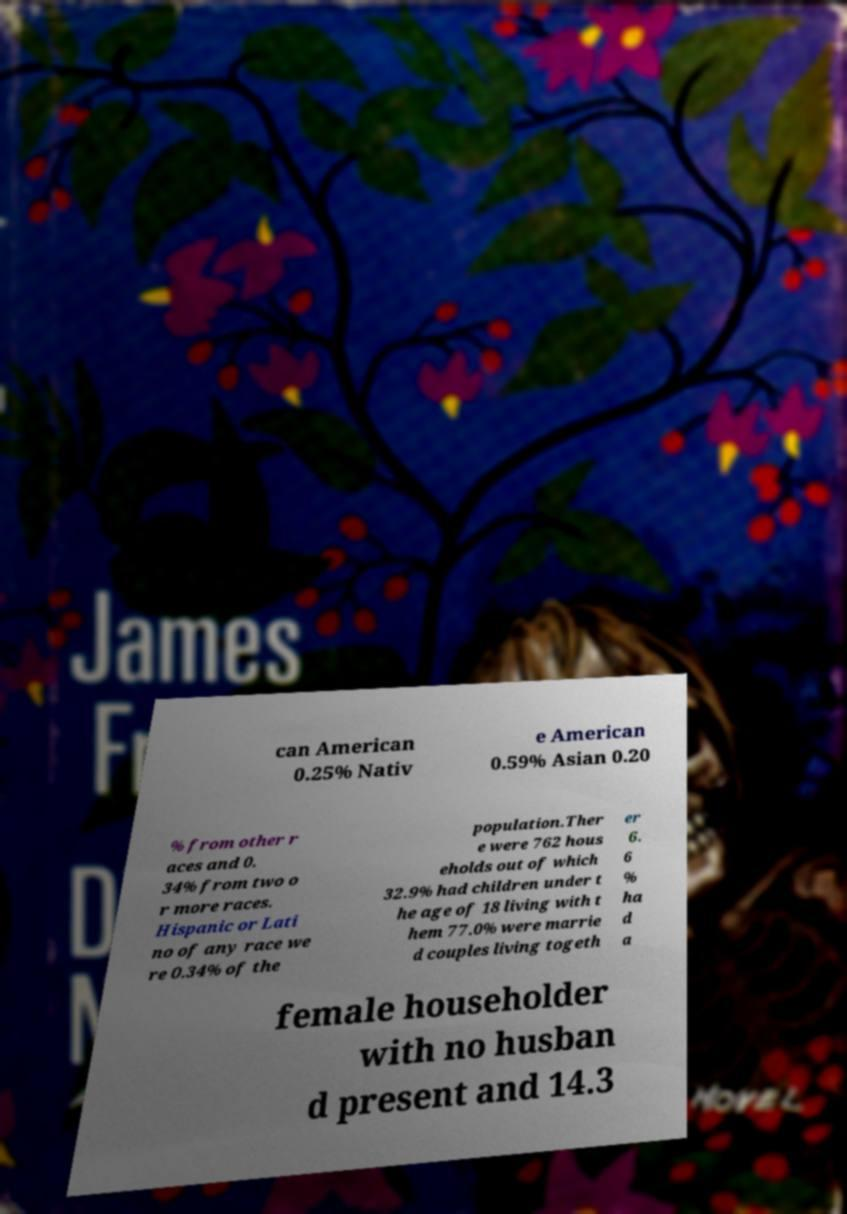Please read and relay the text visible in this image. What does it say? can American 0.25% Nativ e American 0.59% Asian 0.20 % from other r aces and 0. 34% from two o r more races. Hispanic or Lati no of any race we re 0.34% of the population.Ther e were 762 hous eholds out of which 32.9% had children under t he age of 18 living with t hem 77.0% were marrie d couples living togeth er 6. 6 % ha d a female householder with no husban d present and 14.3 